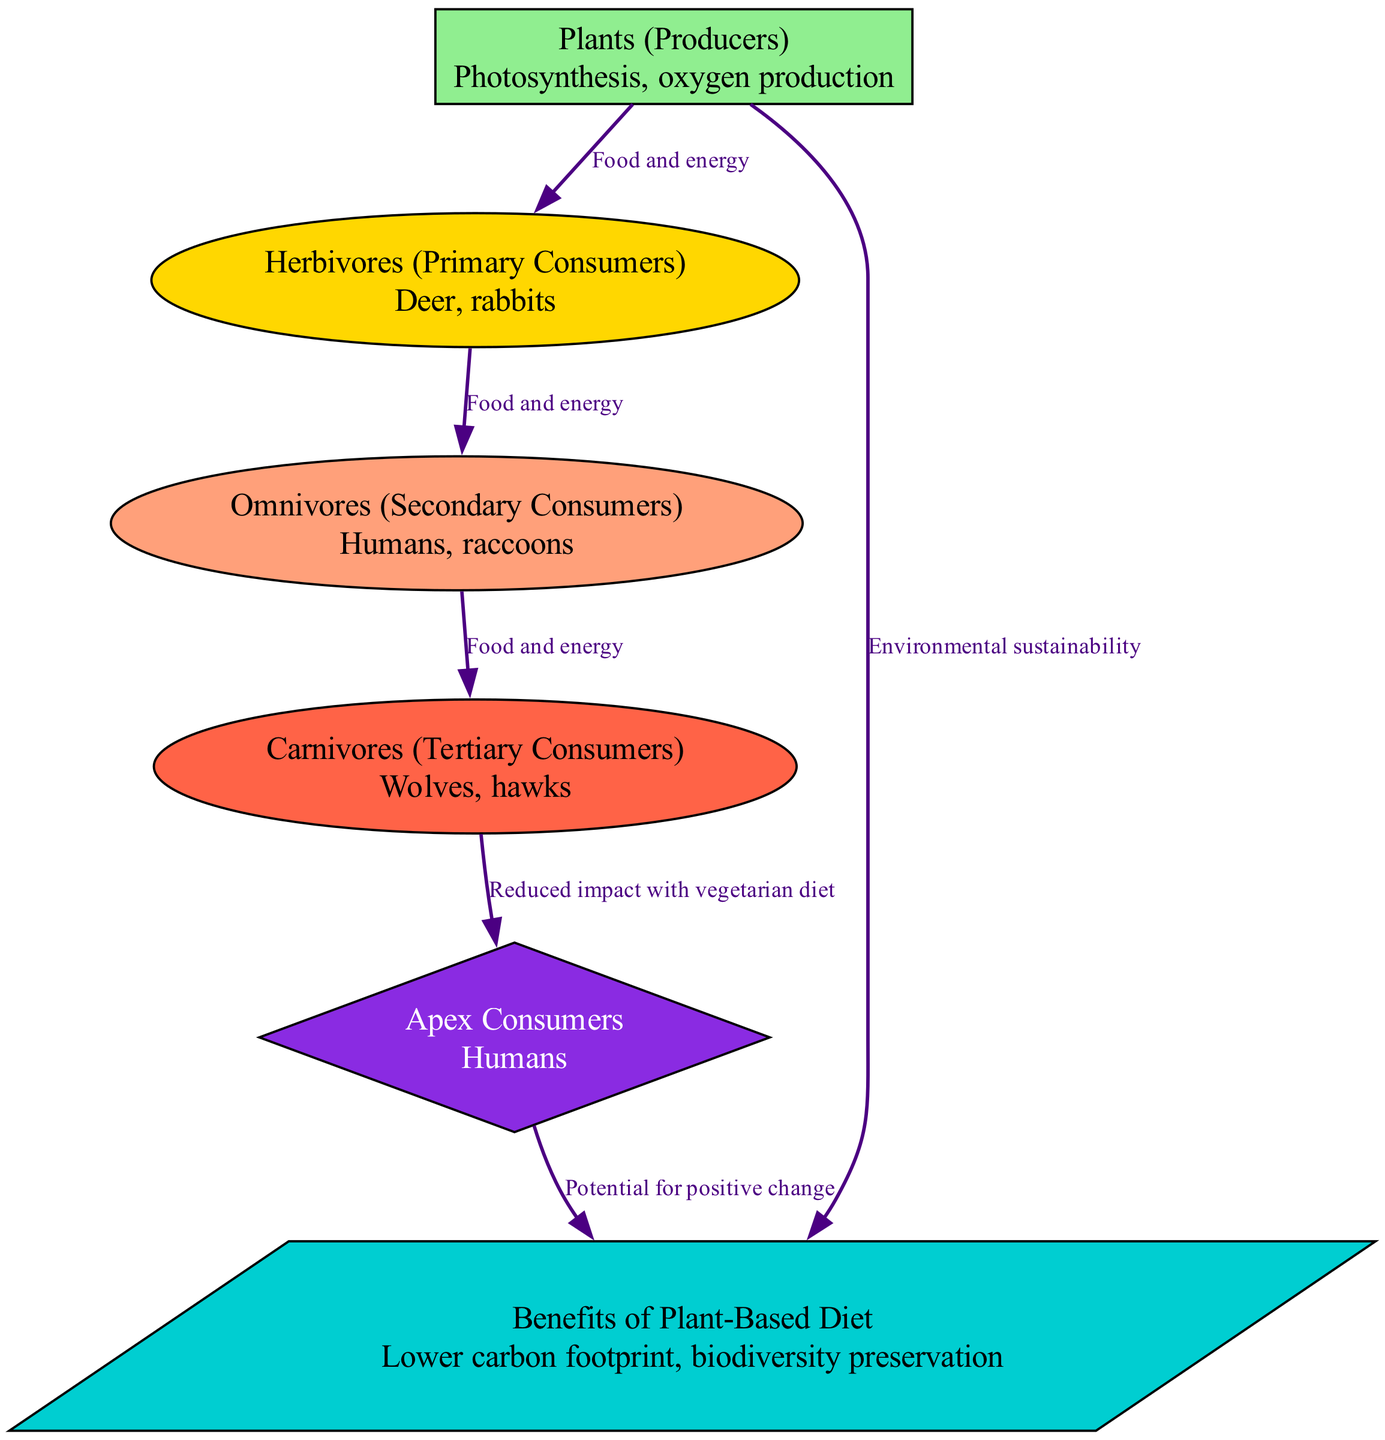What is the apex consumer in the diagram? The apex consumer is the top of the food chain and is represented by the "Apex Consumers" node which specifically mentions "Humans."
Answer: Humans What type of organism are deer classified as? According to the diagram, deer are defined under the "Herbivores (Primary Consumers)" node, which indicates they eat plants.
Answer: Herbivores (Primary Consumers) How many nodes are present in the food chain diagram? Counting all the unique nodes including plants, herbivores, omnivores, carnivores, apex, and benefits, there are six nodes total.
Answer: 6 What is the relationship between plants and herbivores? The relationship is indicated by an edge labeled "Food and energy," which shows that plants provide nourishment to herbivores.
Answer: Food and energy What benefit is associated with a plant-based diet according to the diagram? The diagram lists "Lower carbon footprint, biodiversity preservation" under the benefits associated with a plant-based diet.
Answer: Lower carbon footprint, biodiversity preservation What type of consumers are humans classified as? Humans are categorized as "Omnivores (Secondary Consumers)" in the diagram, indicating they consume both plants and animals.
Answer: Omnivores (Secondary Consumers) Explain the impact of a vegetarian diet on carnivores in this diagram. The edge from "Carnivores" to "Apex" states "Reduced impact with vegetarian diet," suggesting that adopting a vegetarian diet can lessen the ecological footprint of carnivores affecting the ecosystem.
Answer: Reduced impact with vegetarian diet What do the plants contribute to the environment? The diagram shows an edge from "Plants" to "Benefits of Plant-Based Diet" indicating they promote "Environmental sustainability."
Answer: Environmental sustainability Which group directly consumes herbivores? The "Omnivores (Secondary Consumers)" group is directly connected to herbivores indicating they consume them for energy.
Answer: Omnivores (Secondary Consumers) 